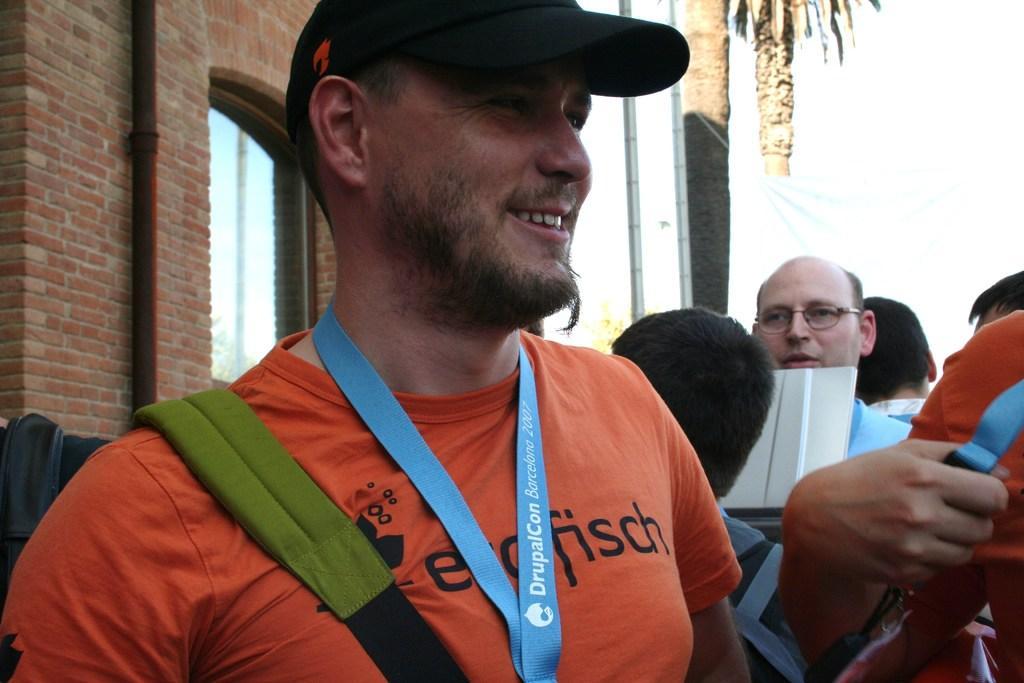In one or two sentences, can you explain what this image depicts? Here we can see people. This man wore tag, cap and smiling. Background there is a windows, brick wall and trees. 